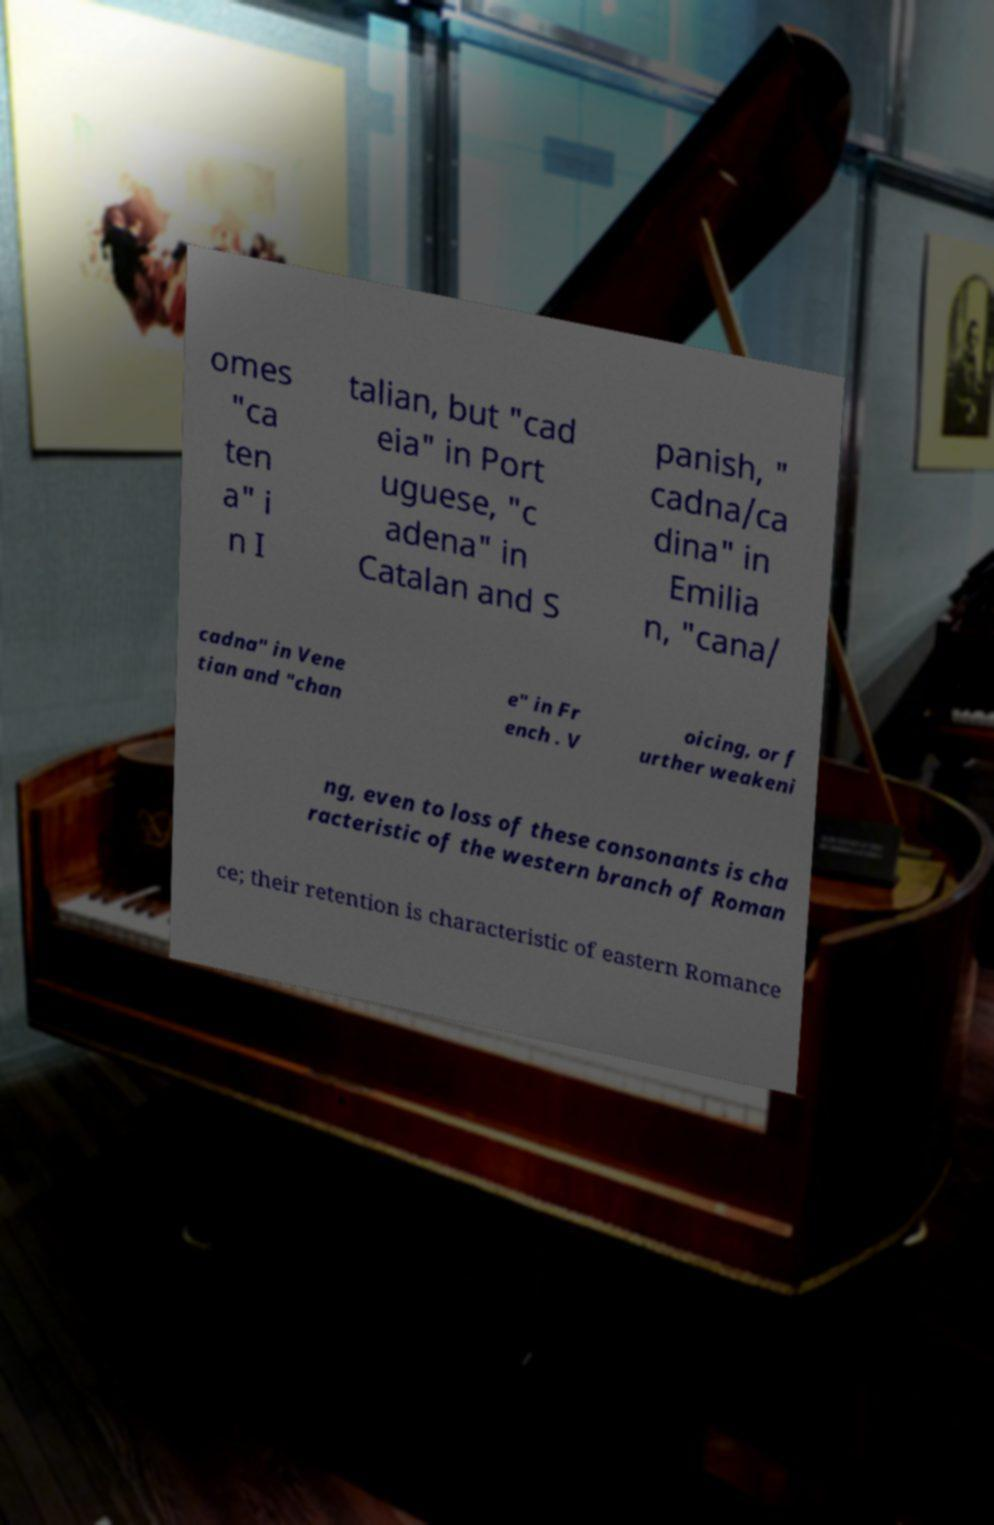I need the written content from this picture converted into text. Can you do that? omes "ca ten a" i n I talian, but "cad eia" in Port uguese, "c adena" in Catalan and S panish, " cadna/ca dina" in Emilia n, "cana/ cadna" in Vene tian and "chan e" in Fr ench . V oicing, or f urther weakeni ng, even to loss of these consonants is cha racteristic of the western branch of Roman ce; their retention is characteristic of eastern Romance 